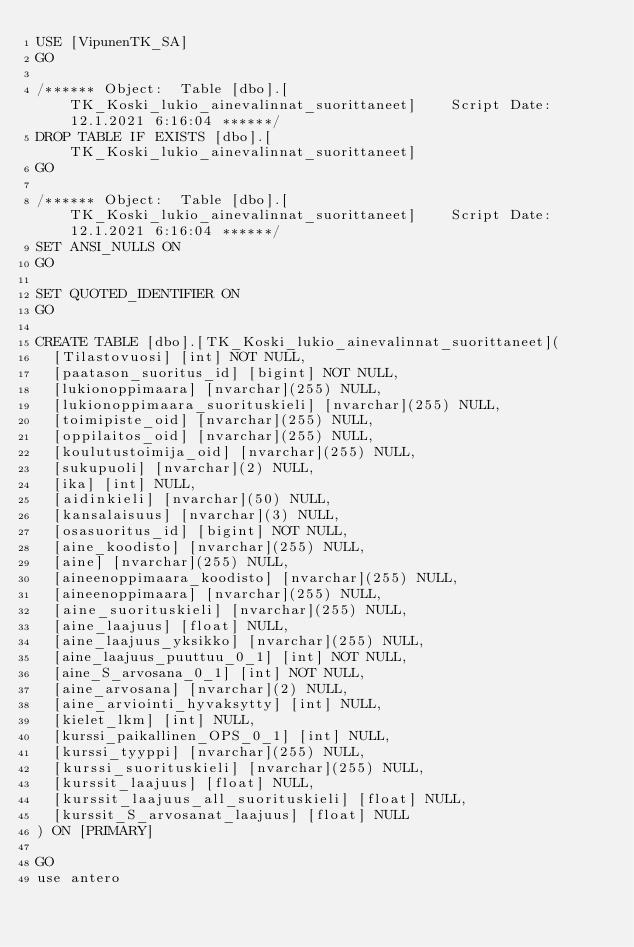<code> <loc_0><loc_0><loc_500><loc_500><_SQL_>USE [VipunenTK_SA]
GO

/****** Object:  Table [dbo].[TK_Koski_lukio_ainevalinnat_suorittaneet]    Script Date: 12.1.2021 6:16:04 ******/
DROP TABLE IF EXISTS [dbo].[TK_Koski_lukio_ainevalinnat_suorittaneet]
GO

/****** Object:  Table [dbo].[TK_Koski_lukio_ainevalinnat_suorittaneet]    Script Date: 12.1.2021 6:16:04 ******/
SET ANSI_NULLS ON
GO

SET QUOTED_IDENTIFIER ON
GO

CREATE TABLE [dbo].[TK_Koski_lukio_ainevalinnat_suorittaneet](
	[Tilastovuosi] [int] NOT NULL,
	[paatason_suoritus_id] [bigint] NOT NULL,
	[lukionoppimaara] [nvarchar](255) NULL,
	[lukionoppimaara_suorituskieli] [nvarchar](255) NULL,
	[toimipiste_oid] [nvarchar](255) NULL,
	[oppilaitos_oid] [nvarchar](255) NULL,
	[koulutustoimija_oid] [nvarchar](255) NULL,
	[sukupuoli] [nvarchar](2) NULL,
	[ika] [int] NULL,
	[aidinkieli] [nvarchar](50) NULL,
	[kansalaisuus] [nvarchar](3) NULL,
	[osasuoritus_id] [bigint] NOT NULL,
	[aine_koodisto] [nvarchar](255) NULL,
	[aine] [nvarchar](255) NULL,
	[aineenoppimaara_koodisto] [nvarchar](255) NULL,
	[aineenoppimaara] [nvarchar](255) NULL,
	[aine_suorituskieli] [nvarchar](255) NULL,
	[aine_laajuus] [float] NULL,
	[aine_laajuus_yksikko] [nvarchar](255) NULL,
	[aine_laajuus_puuttuu_0_1] [int] NOT NULL,
	[aine_S_arvosana_0_1] [int] NOT NULL,
	[aine_arvosana] [nvarchar](2) NULL,
	[aine_arviointi_hyvaksytty] [int] NULL,
	[kielet_lkm] [int] NULL,
	[kurssi_paikallinen_OPS_0_1] [int] NULL,
	[kurssi_tyyppi] [nvarchar](255) NULL,
	[kurssi_suorituskieli] [nvarchar](255) NULL,
	[kurssit_laajuus] [float] NULL,
	[kurssit_laajuus_all_suorituskieli] [float] NULL,
	[kurssit_S_arvosanat_laajuus] [float] NULL
) ON [PRIMARY]

GO
use antero


</code> 